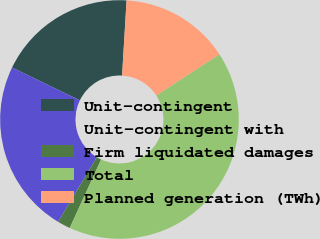Convert chart to OTSL. <chart><loc_0><loc_0><loc_500><loc_500><pie_chart><fcel>Unit-contingent<fcel>Unit-contingent with<fcel>Firm liquidated damages<fcel>Total<fcel>Planned generation (TWh)<nl><fcel>18.78%<fcel>23.58%<fcel>1.75%<fcel>41.05%<fcel>14.85%<nl></chart> 